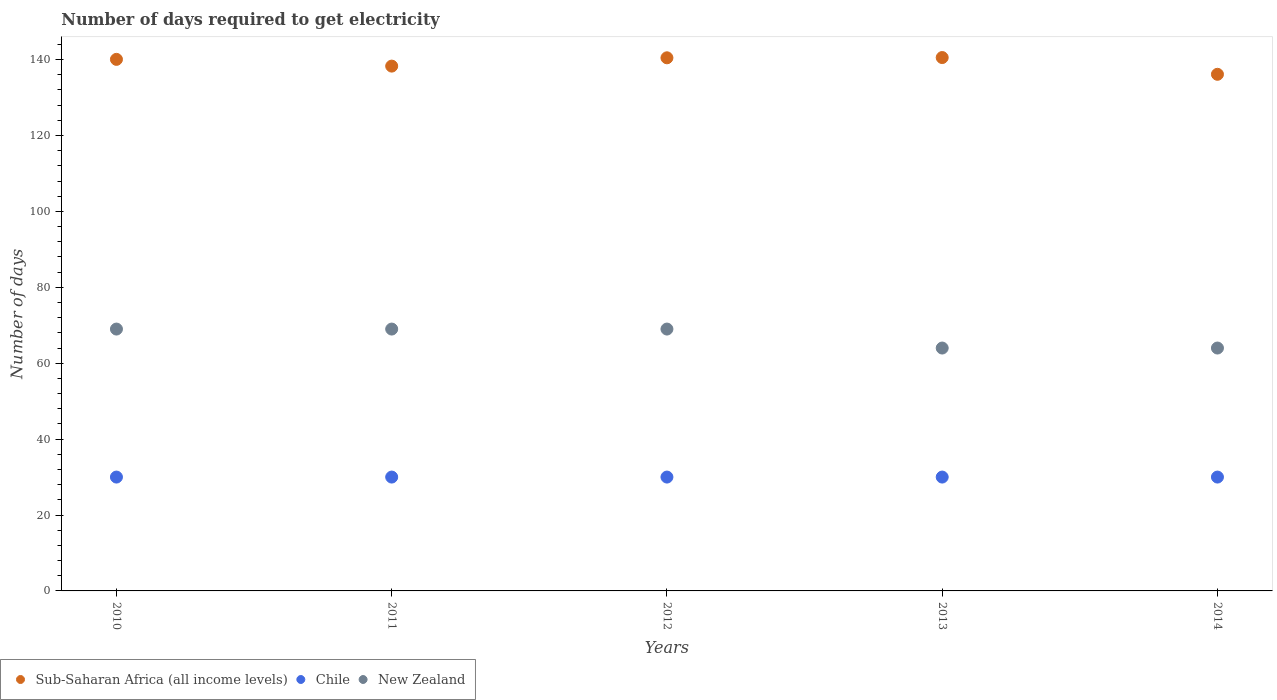Is the number of dotlines equal to the number of legend labels?
Your response must be concise. Yes. What is the number of days required to get electricity in in Chile in 2012?
Offer a terse response. 30. Across all years, what is the maximum number of days required to get electricity in in Sub-Saharan Africa (all income levels)?
Keep it short and to the point. 140.54. Across all years, what is the minimum number of days required to get electricity in in New Zealand?
Your response must be concise. 64. In which year was the number of days required to get electricity in in New Zealand maximum?
Offer a terse response. 2010. What is the total number of days required to get electricity in in Chile in the graph?
Ensure brevity in your answer.  150. What is the difference between the number of days required to get electricity in in Chile in 2013 and that in 2014?
Your answer should be very brief. 0. What is the difference between the number of days required to get electricity in in New Zealand in 2014 and the number of days required to get electricity in in Chile in 2010?
Your answer should be very brief. 34. What is the average number of days required to get electricity in in New Zealand per year?
Offer a terse response. 67. In the year 2014, what is the difference between the number of days required to get electricity in in New Zealand and number of days required to get electricity in in Sub-Saharan Africa (all income levels)?
Provide a short and direct response. -72.13. In how many years, is the number of days required to get electricity in in Sub-Saharan Africa (all income levels) greater than 68 days?
Your answer should be compact. 5. What is the ratio of the number of days required to get electricity in in Sub-Saharan Africa (all income levels) in 2011 to that in 2012?
Your response must be concise. 0.98. Is the number of days required to get electricity in in Chile in 2011 less than that in 2014?
Provide a short and direct response. No. What is the difference between the highest and the lowest number of days required to get electricity in in Chile?
Provide a short and direct response. 0. In how many years, is the number of days required to get electricity in in Chile greater than the average number of days required to get electricity in in Chile taken over all years?
Your answer should be very brief. 0. Is it the case that in every year, the sum of the number of days required to get electricity in in Chile and number of days required to get electricity in in New Zealand  is greater than the number of days required to get electricity in in Sub-Saharan Africa (all income levels)?
Make the answer very short. No. Is the number of days required to get electricity in in Sub-Saharan Africa (all income levels) strictly greater than the number of days required to get electricity in in Chile over the years?
Your answer should be compact. Yes. Are the values on the major ticks of Y-axis written in scientific E-notation?
Your answer should be compact. No. Does the graph contain grids?
Your answer should be very brief. No. How many legend labels are there?
Ensure brevity in your answer.  3. What is the title of the graph?
Keep it short and to the point. Number of days required to get electricity. What is the label or title of the Y-axis?
Provide a succinct answer. Number of days. What is the Number of days of Sub-Saharan Africa (all income levels) in 2010?
Give a very brief answer. 140.07. What is the Number of days in Chile in 2010?
Provide a short and direct response. 30. What is the Number of days in New Zealand in 2010?
Offer a very short reply. 69. What is the Number of days in Sub-Saharan Africa (all income levels) in 2011?
Offer a very short reply. 138.29. What is the Number of days in Sub-Saharan Africa (all income levels) in 2012?
Provide a short and direct response. 140.48. What is the Number of days of Chile in 2012?
Your response must be concise. 30. What is the Number of days of Sub-Saharan Africa (all income levels) in 2013?
Your answer should be compact. 140.54. What is the Number of days in Chile in 2013?
Ensure brevity in your answer.  30. What is the Number of days of New Zealand in 2013?
Your response must be concise. 64. What is the Number of days of Sub-Saharan Africa (all income levels) in 2014?
Give a very brief answer. 136.13. Across all years, what is the maximum Number of days of Sub-Saharan Africa (all income levels)?
Ensure brevity in your answer.  140.54. Across all years, what is the minimum Number of days in Sub-Saharan Africa (all income levels)?
Provide a short and direct response. 136.13. Across all years, what is the minimum Number of days of Chile?
Provide a short and direct response. 30. What is the total Number of days in Sub-Saharan Africa (all income levels) in the graph?
Give a very brief answer. 695.51. What is the total Number of days in Chile in the graph?
Provide a succinct answer. 150. What is the total Number of days of New Zealand in the graph?
Make the answer very short. 335. What is the difference between the Number of days of Sub-Saharan Africa (all income levels) in 2010 and that in 2011?
Offer a terse response. 1.78. What is the difference between the Number of days of New Zealand in 2010 and that in 2011?
Give a very brief answer. 0. What is the difference between the Number of days in Sub-Saharan Africa (all income levels) in 2010 and that in 2012?
Your answer should be very brief. -0.41. What is the difference between the Number of days of Sub-Saharan Africa (all income levels) in 2010 and that in 2013?
Offer a terse response. -0.48. What is the difference between the Number of days of Sub-Saharan Africa (all income levels) in 2010 and that in 2014?
Offer a very short reply. 3.93. What is the difference between the Number of days in Chile in 2010 and that in 2014?
Provide a short and direct response. 0. What is the difference between the Number of days in New Zealand in 2010 and that in 2014?
Your answer should be compact. 5. What is the difference between the Number of days of Sub-Saharan Africa (all income levels) in 2011 and that in 2012?
Keep it short and to the point. -2.19. What is the difference between the Number of days of Chile in 2011 and that in 2012?
Give a very brief answer. 0. What is the difference between the Number of days of New Zealand in 2011 and that in 2012?
Your answer should be very brief. 0. What is the difference between the Number of days of Sub-Saharan Africa (all income levels) in 2011 and that in 2013?
Give a very brief answer. -2.26. What is the difference between the Number of days in Sub-Saharan Africa (all income levels) in 2011 and that in 2014?
Give a very brief answer. 2.16. What is the difference between the Number of days in Sub-Saharan Africa (all income levels) in 2012 and that in 2013?
Ensure brevity in your answer.  -0.07. What is the difference between the Number of days in Chile in 2012 and that in 2013?
Give a very brief answer. 0. What is the difference between the Number of days of Sub-Saharan Africa (all income levels) in 2012 and that in 2014?
Offer a very short reply. 4.35. What is the difference between the Number of days of Sub-Saharan Africa (all income levels) in 2013 and that in 2014?
Keep it short and to the point. 4.41. What is the difference between the Number of days of Sub-Saharan Africa (all income levels) in 2010 and the Number of days of Chile in 2011?
Make the answer very short. 110.07. What is the difference between the Number of days of Sub-Saharan Africa (all income levels) in 2010 and the Number of days of New Zealand in 2011?
Your answer should be very brief. 71.07. What is the difference between the Number of days of Chile in 2010 and the Number of days of New Zealand in 2011?
Your answer should be compact. -39. What is the difference between the Number of days of Sub-Saharan Africa (all income levels) in 2010 and the Number of days of Chile in 2012?
Give a very brief answer. 110.07. What is the difference between the Number of days of Sub-Saharan Africa (all income levels) in 2010 and the Number of days of New Zealand in 2012?
Your response must be concise. 71.07. What is the difference between the Number of days in Chile in 2010 and the Number of days in New Zealand in 2012?
Make the answer very short. -39. What is the difference between the Number of days in Sub-Saharan Africa (all income levels) in 2010 and the Number of days in Chile in 2013?
Keep it short and to the point. 110.07. What is the difference between the Number of days in Sub-Saharan Africa (all income levels) in 2010 and the Number of days in New Zealand in 2013?
Provide a short and direct response. 76.07. What is the difference between the Number of days of Chile in 2010 and the Number of days of New Zealand in 2013?
Ensure brevity in your answer.  -34. What is the difference between the Number of days in Sub-Saharan Africa (all income levels) in 2010 and the Number of days in Chile in 2014?
Make the answer very short. 110.07. What is the difference between the Number of days in Sub-Saharan Africa (all income levels) in 2010 and the Number of days in New Zealand in 2014?
Provide a short and direct response. 76.07. What is the difference between the Number of days of Chile in 2010 and the Number of days of New Zealand in 2014?
Provide a succinct answer. -34. What is the difference between the Number of days in Sub-Saharan Africa (all income levels) in 2011 and the Number of days in Chile in 2012?
Offer a terse response. 108.29. What is the difference between the Number of days of Sub-Saharan Africa (all income levels) in 2011 and the Number of days of New Zealand in 2012?
Provide a succinct answer. 69.29. What is the difference between the Number of days in Chile in 2011 and the Number of days in New Zealand in 2012?
Provide a succinct answer. -39. What is the difference between the Number of days of Sub-Saharan Africa (all income levels) in 2011 and the Number of days of Chile in 2013?
Your answer should be compact. 108.29. What is the difference between the Number of days in Sub-Saharan Africa (all income levels) in 2011 and the Number of days in New Zealand in 2013?
Provide a short and direct response. 74.29. What is the difference between the Number of days of Chile in 2011 and the Number of days of New Zealand in 2013?
Offer a terse response. -34. What is the difference between the Number of days of Sub-Saharan Africa (all income levels) in 2011 and the Number of days of Chile in 2014?
Your answer should be very brief. 108.29. What is the difference between the Number of days of Sub-Saharan Africa (all income levels) in 2011 and the Number of days of New Zealand in 2014?
Your answer should be very brief. 74.29. What is the difference between the Number of days of Chile in 2011 and the Number of days of New Zealand in 2014?
Offer a terse response. -34. What is the difference between the Number of days of Sub-Saharan Africa (all income levels) in 2012 and the Number of days of Chile in 2013?
Provide a succinct answer. 110.48. What is the difference between the Number of days in Sub-Saharan Africa (all income levels) in 2012 and the Number of days in New Zealand in 2013?
Offer a terse response. 76.48. What is the difference between the Number of days in Chile in 2012 and the Number of days in New Zealand in 2013?
Your answer should be very brief. -34. What is the difference between the Number of days in Sub-Saharan Africa (all income levels) in 2012 and the Number of days in Chile in 2014?
Make the answer very short. 110.48. What is the difference between the Number of days of Sub-Saharan Africa (all income levels) in 2012 and the Number of days of New Zealand in 2014?
Provide a short and direct response. 76.48. What is the difference between the Number of days in Chile in 2012 and the Number of days in New Zealand in 2014?
Keep it short and to the point. -34. What is the difference between the Number of days in Sub-Saharan Africa (all income levels) in 2013 and the Number of days in Chile in 2014?
Make the answer very short. 110.54. What is the difference between the Number of days of Sub-Saharan Africa (all income levels) in 2013 and the Number of days of New Zealand in 2014?
Your answer should be very brief. 76.54. What is the difference between the Number of days of Chile in 2013 and the Number of days of New Zealand in 2014?
Your answer should be very brief. -34. What is the average Number of days in Sub-Saharan Africa (all income levels) per year?
Provide a short and direct response. 139.1. What is the average Number of days in Chile per year?
Provide a short and direct response. 30. In the year 2010, what is the difference between the Number of days of Sub-Saharan Africa (all income levels) and Number of days of Chile?
Your answer should be compact. 110.07. In the year 2010, what is the difference between the Number of days of Sub-Saharan Africa (all income levels) and Number of days of New Zealand?
Keep it short and to the point. 71.07. In the year 2010, what is the difference between the Number of days in Chile and Number of days in New Zealand?
Keep it short and to the point. -39. In the year 2011, what is the difference between the Number of days in Sub-Saharan Africa (all income levels) and Number of days in Chile?
Give a very brief answer. 108.29. In the year 2011, what is the difference between the Number of days in Sub-Saharan Africa (all income levels) and Number of days in New Zealand?
Ensure brevity in your answer.  69.29. In the year 2011, what is the difference between the Number of days in Chile and Number of days in New Zealand?
Keep it short and to the point. -39. In the year 2012, what is the difference between the Number of days in Sub-Saharan Africa (all income levels) and Number of days in Chile?
Offer a terse response. 110.48. In the year 2012, what is the difference between the Number of days in Sub-Saharan Africa (all income levels) and Number of days in New Zealand?
Provide a succinct answer. 71.48. In the year 2012, what is the difference between the Number of days of Chile and Number of days of New Zealand?
Your response must be concise. -39. In the year 2013, what is the difference between the Number of days in Sub-Saharan Africa (all income levels) and Number of days in Chile?
Keep it short and to the point. 110.54. In the year 2013, what is the difference between the Number of days in Sub-Saharan Africa (all income levels) and Number of days in New Zealand?
Offer a very short reply. 76.54. In the year 2013, what is the difference between the Number of days of Chile and Number of days of New Zealand?
Ensure brevity in your answer.  -34. In the year 2014, what is the difference between the Number of days of Sub-Saharan Africa (all income levels) and Number of days of Chile?
Provide a succinct answer. 106.13. In the year 2014, what is the difference between the Number of days in Sub-Saharan Africa (all income levels) and Number of days in New Zealand?
Keep it short and to the point. 72.13. In the year 2014, what is the difference between the Number of days in Chile and Number of days in New Zealand?
Your response must be concise. -34. What is the ratio of the Number of days in Sub-Saharan Africa (all income levels) in 2010 to that in 2011?
Your answer should be compact. 1.01. What is the ratio of the Number of days in New Zealand in 2010 to that in 2011?
Provide a succinct answer. 1. What is the ratio of the Number of days in Chile in 2010 to that in 2012?
Make the answer very short. 1. What is the ratio of the Number of days of Sub-Saharan Africa (all income levels) in 2010 to that in 2013?
Your answer should be compact. 1. What is the ratio of the Number of days of New Zealand in 2010 to that in 2013?
Give a very brief answer. 1.08. What is the ratio of the Number of days of Sub-Saharan Africa (all income levels) in 2010 to that in 2014?
Give a very brief answer. 1.03. What is the ratio of the Number of days in Chile in 2010 to that in 2014?
Give a very brief answer. 1. What is the ratio of the Number of days in New Zealand in 2010 to that in 2014?
Make the answer very short. 1.08. What is the ratio of the Number of days in Sub-Saharan Africa (all income levels) in 2011 to that in 2012?
Your answer should be compact. 0.98. What is the ratio of the Number of days of New Zealand in 2011 to that in 2012?
Provide a succinct answer. 1. What is the ratio of the Number of days in Sub-Saharan Africa (all income levels) in 2011 to that in 2013?
Your answer should be very brief. 0.98. What is the ratio of the Number of days of Chile in 2011 to that in 2013?
Ensure brevity in your answer.  1. What is the ratio of the Number of days in New Zealand in 2011 to that in 2013?
Your response must be concise. 1.08. What is the ratio of the Number of days in Sub-Saharan Africa (all income levels) in 2011 to that in 2014?
Ensure brevity in your answer.  1.02. What is the ratio of the Number of days of New Zealand in 2011 to that in 2014?
Provide a short and direct response. 1.08. What is the ratio of the Number of days of Chile in 2012 to that in 2013?
Your answer should be very brief. 1. What is the ratio of the Number of days of New Zealand in 2012 to that in 2013?
Offer a very short reply. 1.08. What is the ratio of the Number of days of Sub-Saharan Africa (all income levels) in 2012 to that in 2014?
Ensure brevity in your answer.  1.03. What is the ratio of the Number of days in Chile in 2012 to that in 2014?
Your response must be concise. 1. What is the ratio of the Number of days of New Zealand in 2012 to that in 2014?
Provide a short and direct response. 1.08. What is the ratio of the Number of days of Sub-Saharan Africa (all income levels) in 2013 to that in 2014?
Provide a short and direct response. 1.03. What is the ratio of the Number of days of Chile in 2013 to that in 2014?
Your response must be concise. 1. What is the ratio of the Number of days in New Zealand in 2013 to that in 2014?
Provide a short and direct response. 1. What is the difference between the highest and the second highest Number of days of Sub-Saharan Africa (all income levels)?
Offer a very short reply. 0.07. What is the difference between the highest and the second highest Number of days in New Zealand?
Your answer should be very brief. 0. What is the difference between the highest and the lowest Number of days in Sub-Saharan Africa (all income levels)?
Give a very brief answer. 4.41. What is the difference between the highest and the lowest Number of days of Chile?
Your response must be concise. 0. What is the difference between the highest and the lowest Number of days in New Zealand?
Ensure brevity in your answer.  5. 